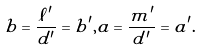<formula> <loc_0><loc_0><loc_500><loc_500>b = \frac { \ell ^ { \prime } } { d ^ { \prime } } = b ^ { \prime } , a = \frac { m ^ { \prime } } { d ^ { \prime } } = a ^ { \prime } .</formula> 